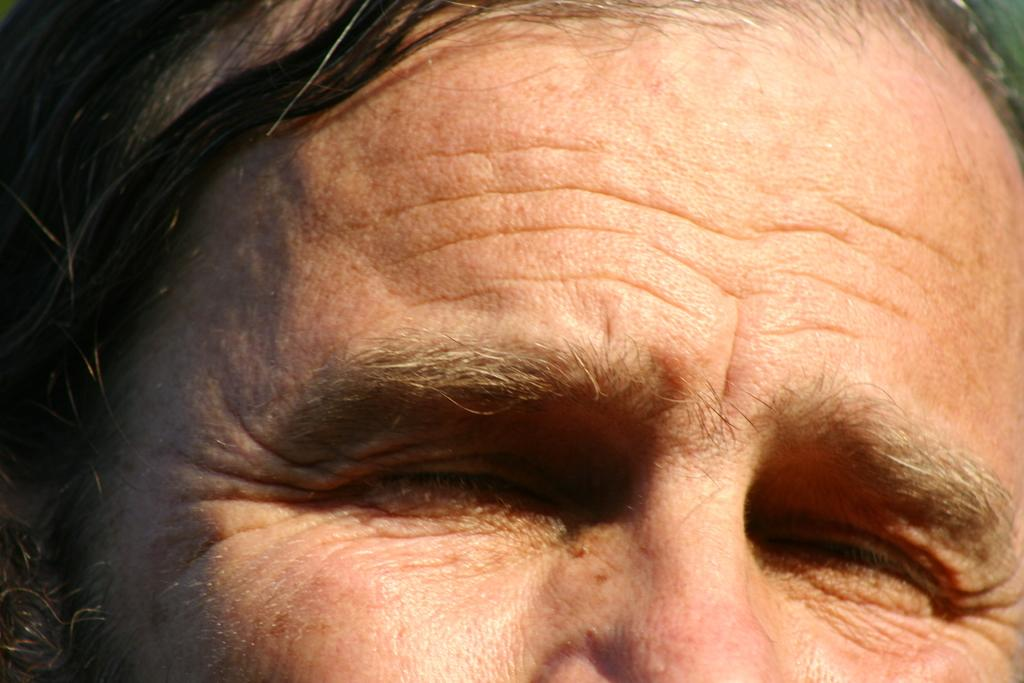What is the main subject of the image? The main subject of the image is the head of a person. What facial features can be seen in the image? There are eyes and a part of the nose visible in the image. What else is visible on the person's head? There is hair visible in the image. How many babies are holding a spade in the image? There are no babies or spades present in the image; it features the head of a person with facial features and hair. 